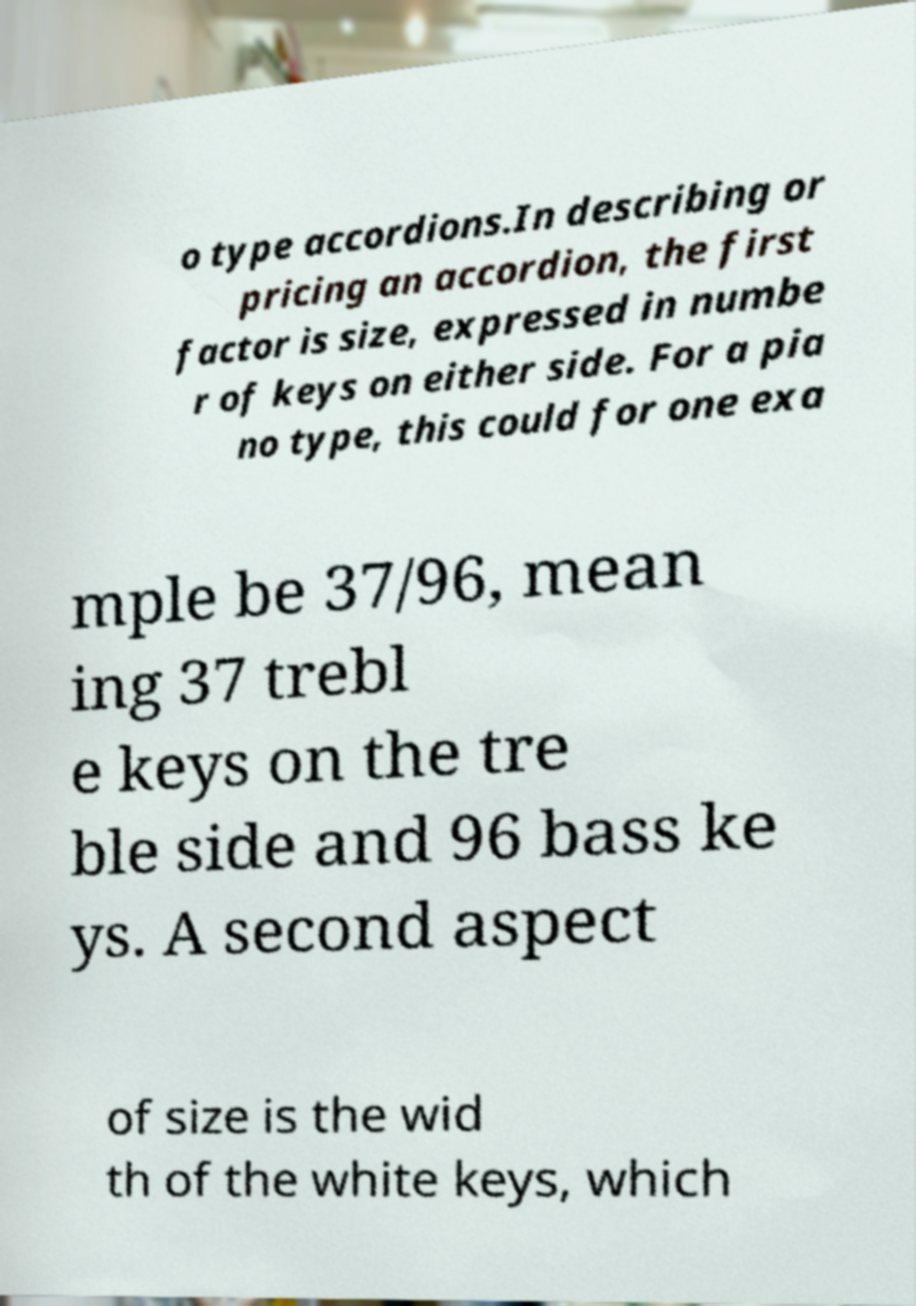I need the written content from this picture converted into text. Can you do that? o type accordions.In describing or pricing an accordion, the first factor is size, expressed in numbe r of keys on either side. For a pia no type, this could for one exa mple be 37/96, mean ing 37 trebl e keys on the tre ble side and 96 bass ke ys. A second aspect of size is the wid th of the white keys, which 